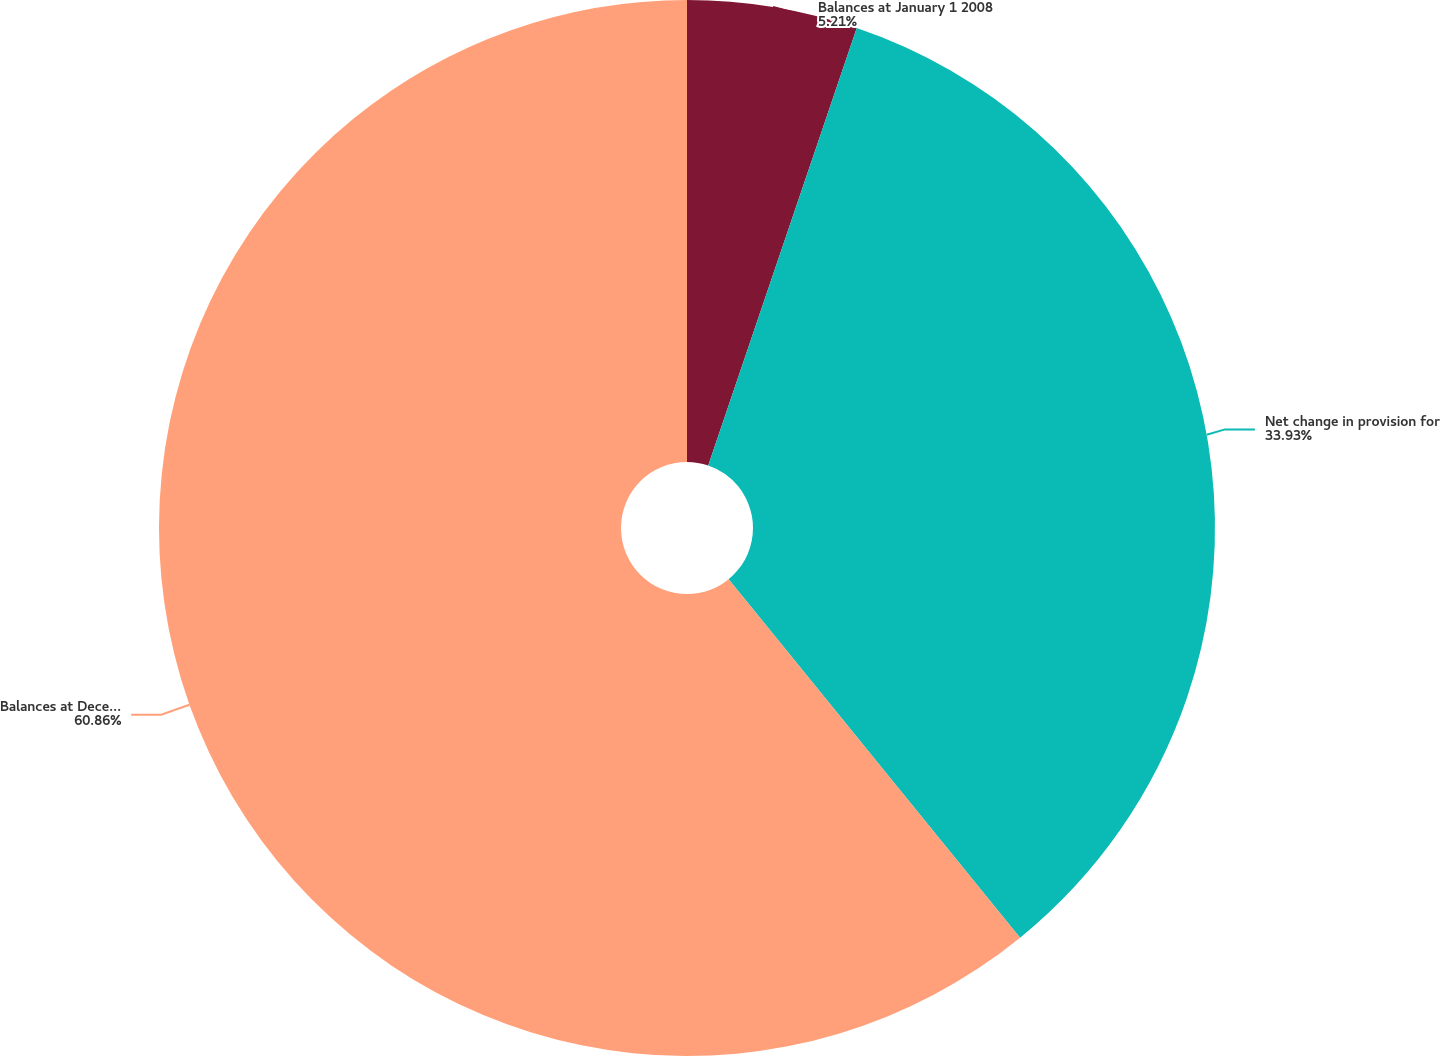Convert chart. <chart><loc_0><loc_0><loc_500><loc_500><pie_chart><fcel>Balances at January 1 2008<fcel>Net change in provision for<fcel>Balances at December 31 2008<nl><fcel>5.21%<fcel>33.93%<fcel>60.87%<nl></chart> 